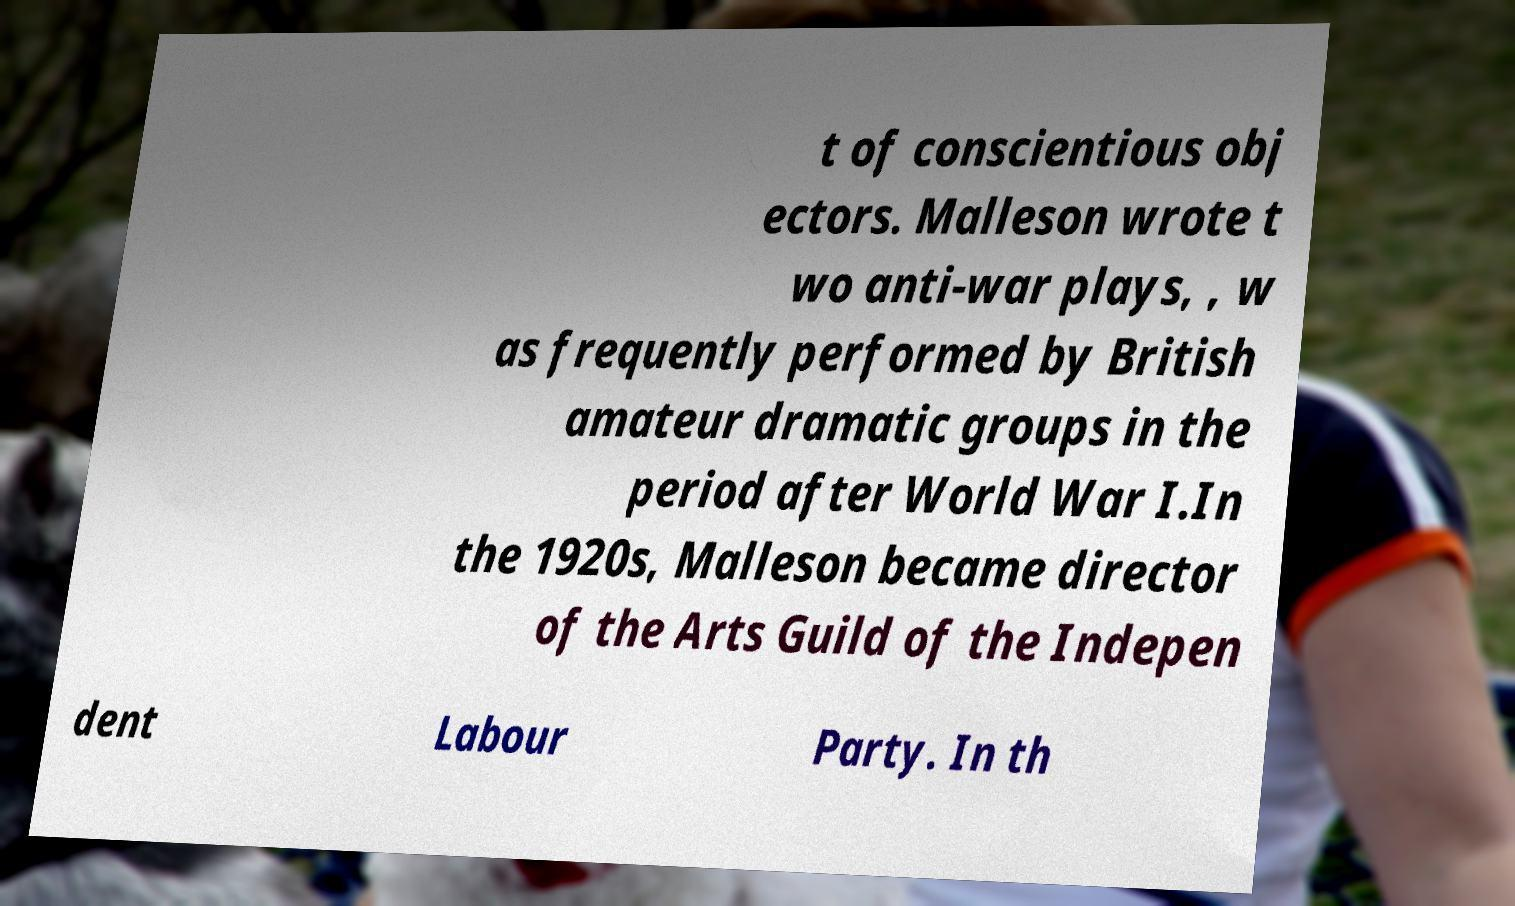I need the written content from this picture converted into text. Can you do that? t of conscientious obj ectors. Malleson wrote t wo anti-war plays, , w as frequently performed by British amateur dramatic groups in the period after World War I.In the 1920s, Malleson became director of the Arts Guild of the Indepen dent Labour Party. In th 